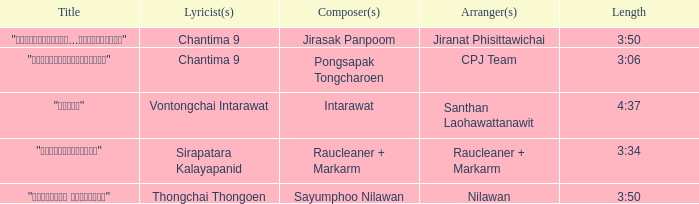Who arranged the song "ขอโทษ"? Santhan Laohawattanawit. 